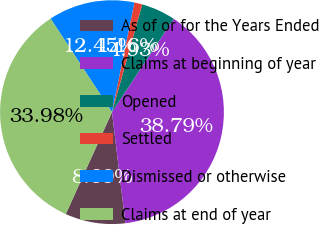Convert chart to OTSL. <chart><loc_0><loc_0><loc_500><loc_500><pie_chart><fcel>As of or for the Years Ended<fcel>Claims at beginning of year<fcel>Opened<fcel>Settled<fcel>Dismissed or otherwise<fcel>Claims at end of year<nl><fcel>8.69%<fcel>38.79%<fcel>4.93%<fcel>1.16%<fcel>12.45%<fcel>33.98%<nl></chart> 